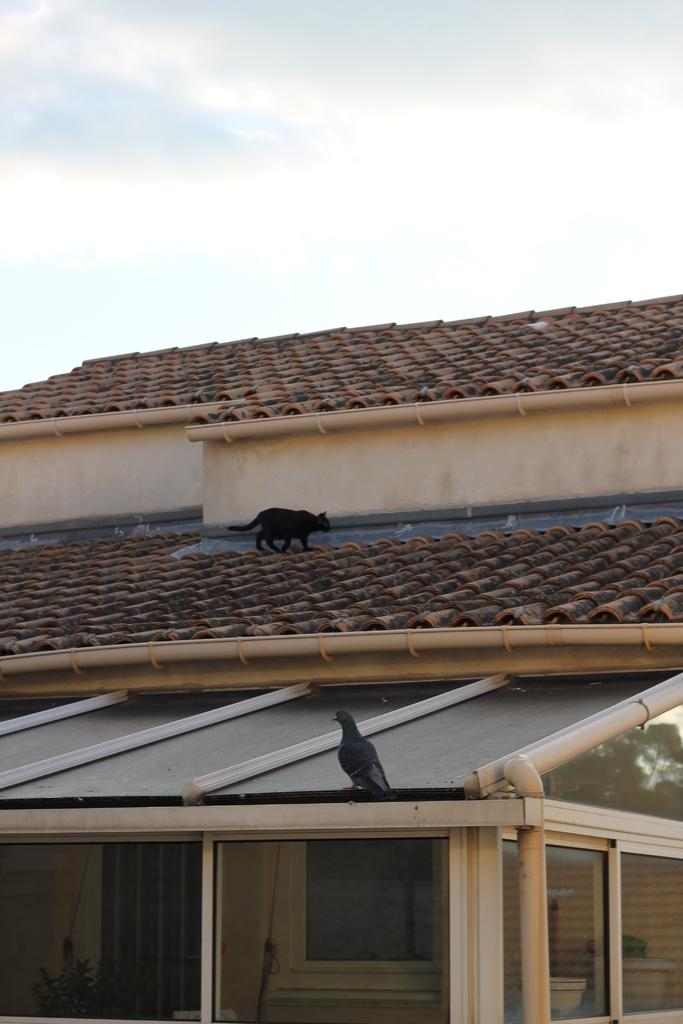What is the main subject of the image? The main subject of the image is the roof of a house. Are there any animals present on the roof? Yes, there is a black color cat and a bird on the roof. What can be seen in the background of the image? The sky is visible in the background of the image. What is the condition of the sky in the image? There are clouds in the sky. How much money is being exchanged between the cat and the bird in the image? There is no exchange of money between the cat and the bird in the image, as they are both animals and do not use money. Can you tell me how the bird is able to cast a spell on the cat in the image? There is no indication of magic or spells in the image; it simply shows a cat and a bird on a roof. 